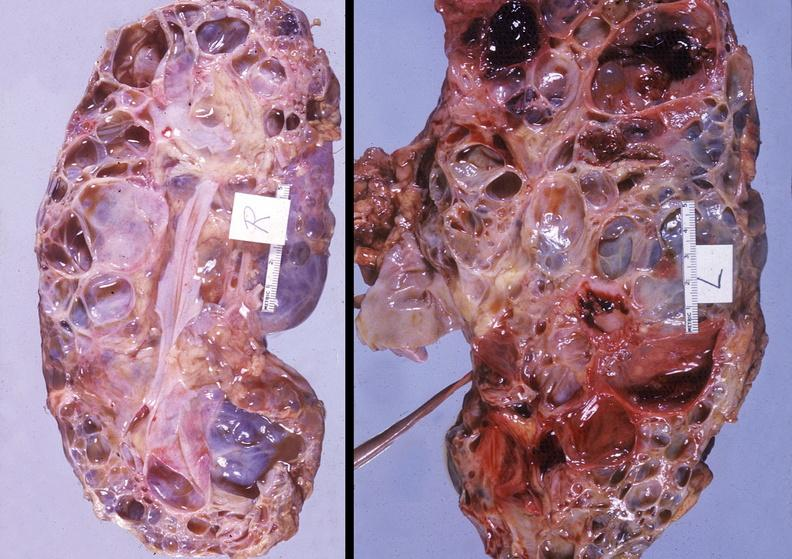where is this?
Answer the question using a single word or phrase. Urinary 